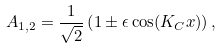<formula> <loc_0><loc_0><loc_500><loc_500>A _ { 1 , 2 } = \frac { 1 } { \sqrt { 2 } } \left ( 1 \pm \epsilon \cos ( K _ { C } x ) \right ) ,</formula> 